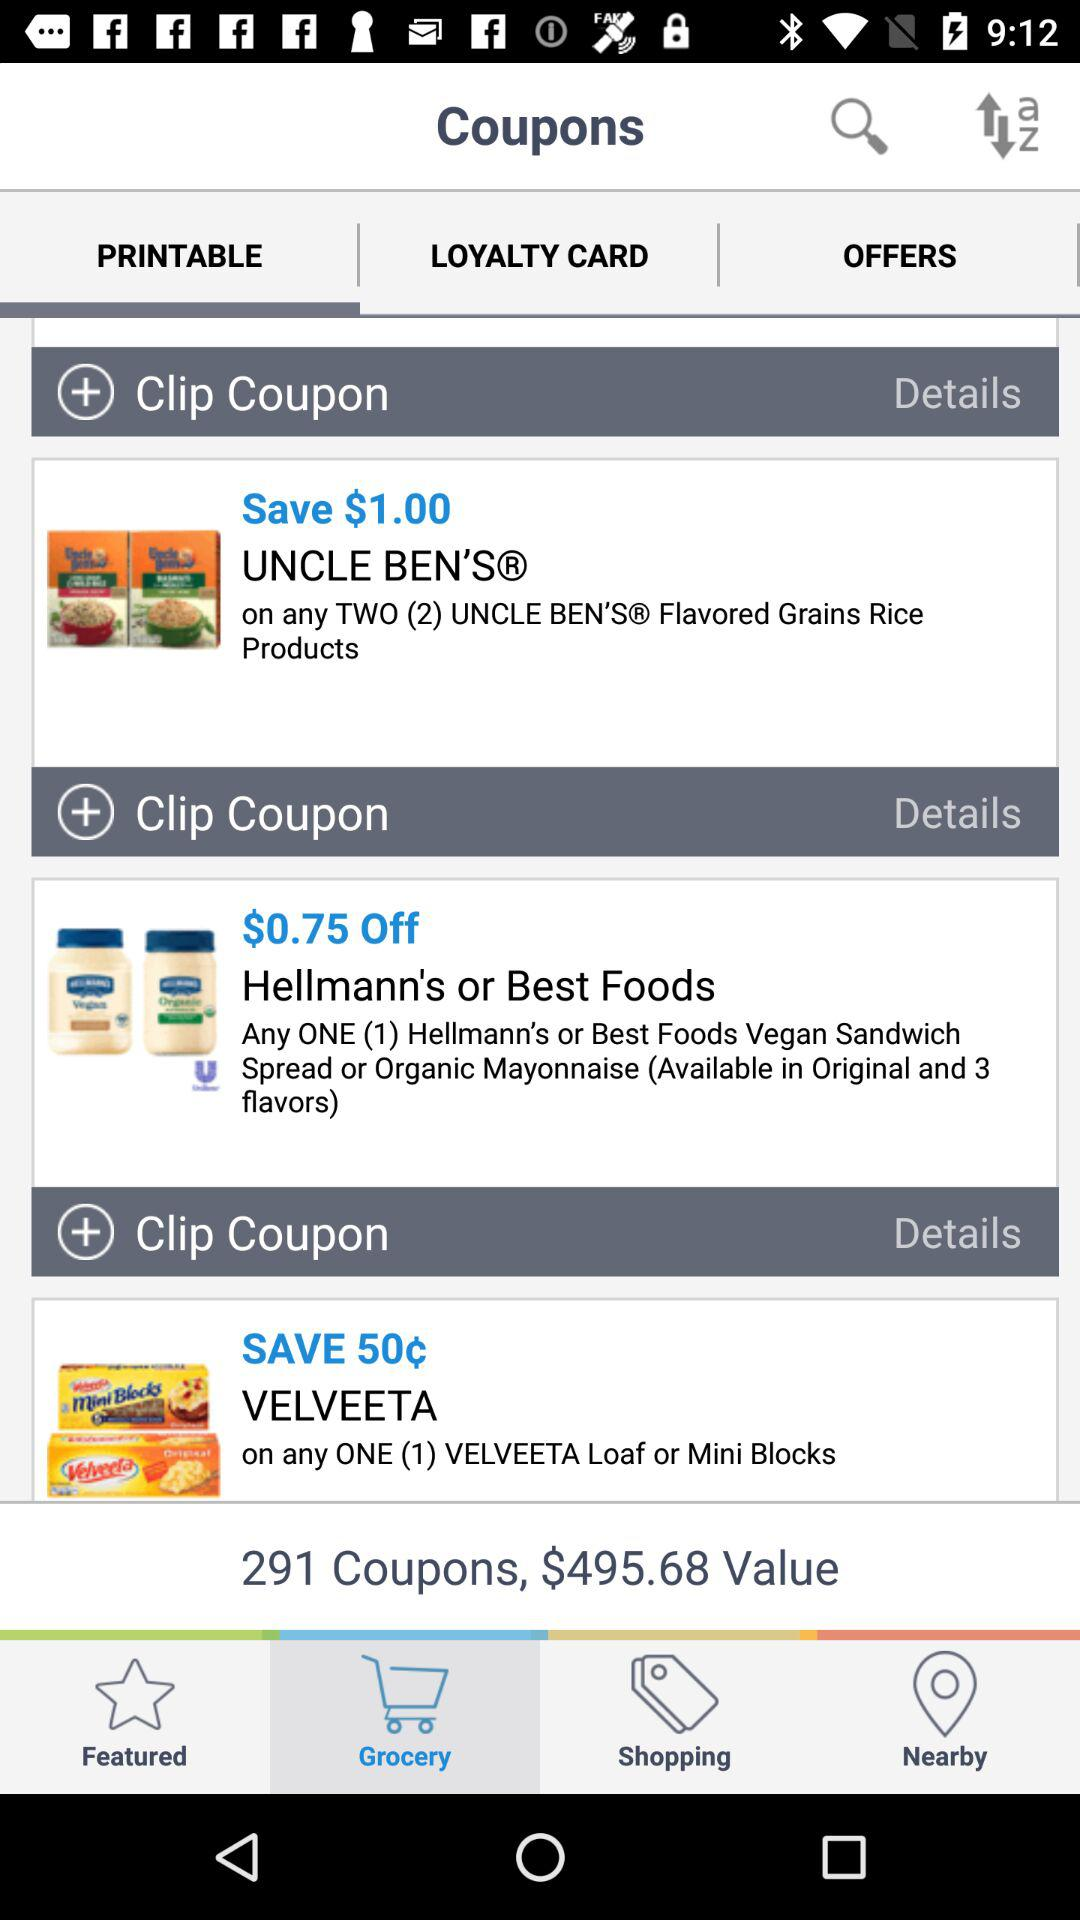How much money can I save by using all of the coupons on this screen?
Answer the question using a single word or phrase. $495.68 